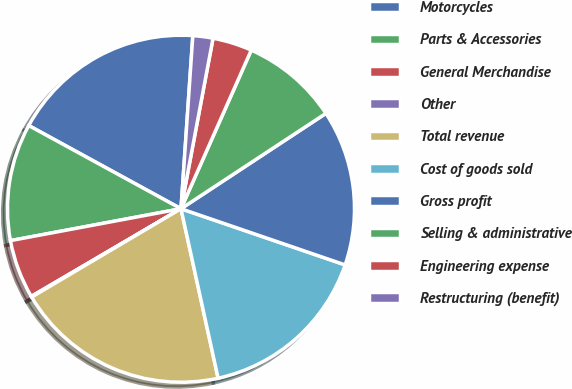<chart> <loc_0><loc_0><loc_500><loc_500><pie_chart><fcel>Motorcycles<fcel>Parts & Accessories<fcel>General Merchandise<fcel>Other<fcel>Total revenue<fcel>Cost of goods sold<fcel>Gross profit<fcel>Selling & administrative<fcel>Engineering expense<fcel>Restructuring (benefit)<nl><fcel>18.13%<fcel>10.9%<fcel>5.49%<fcel>0.07%<fcel>19.93%<fcel>16.32%<fcel>14.51%<fcel>9.1%<fcel>3.68%<fcel>1.87%<nl></chart> 